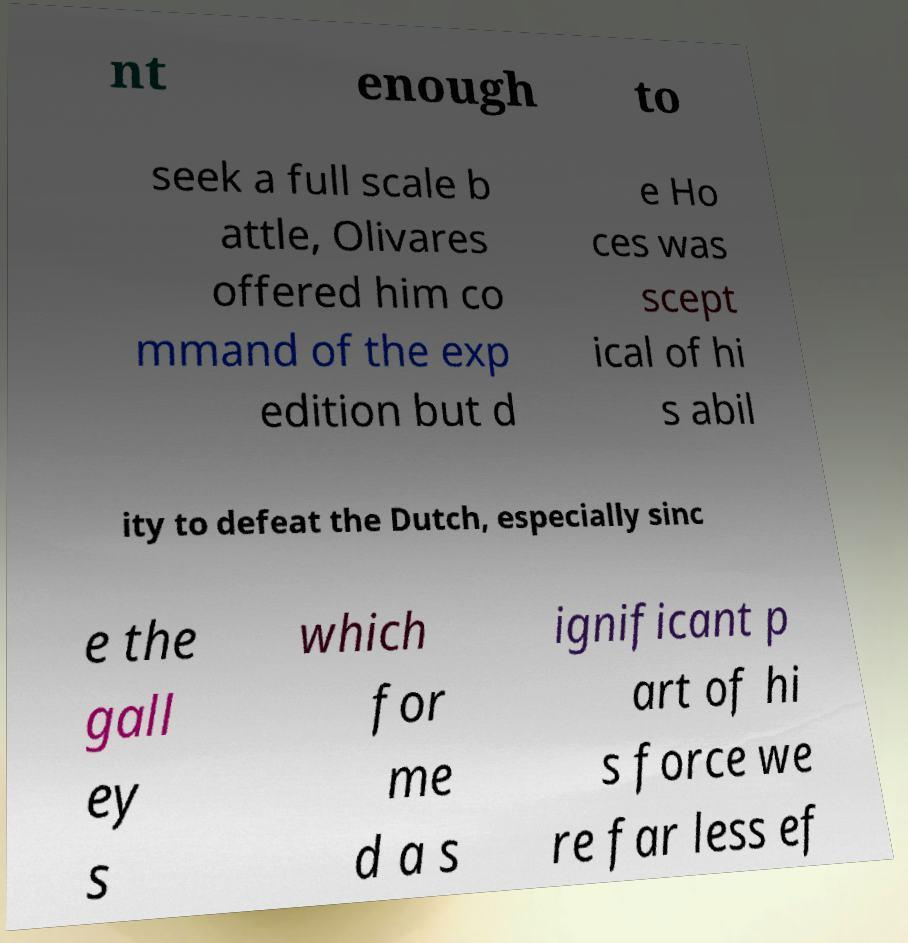Please identify and transcribe the text found in this image. nt enough to seek a full scale b attle, Olivares offered him co mmand of the exp edition but d e Ho ces was scept ical of hi s abil ity to defeat the Dutch, especially sinc e the gall ey s which for me d a s ignificant p art of hi s force we re far less ef 